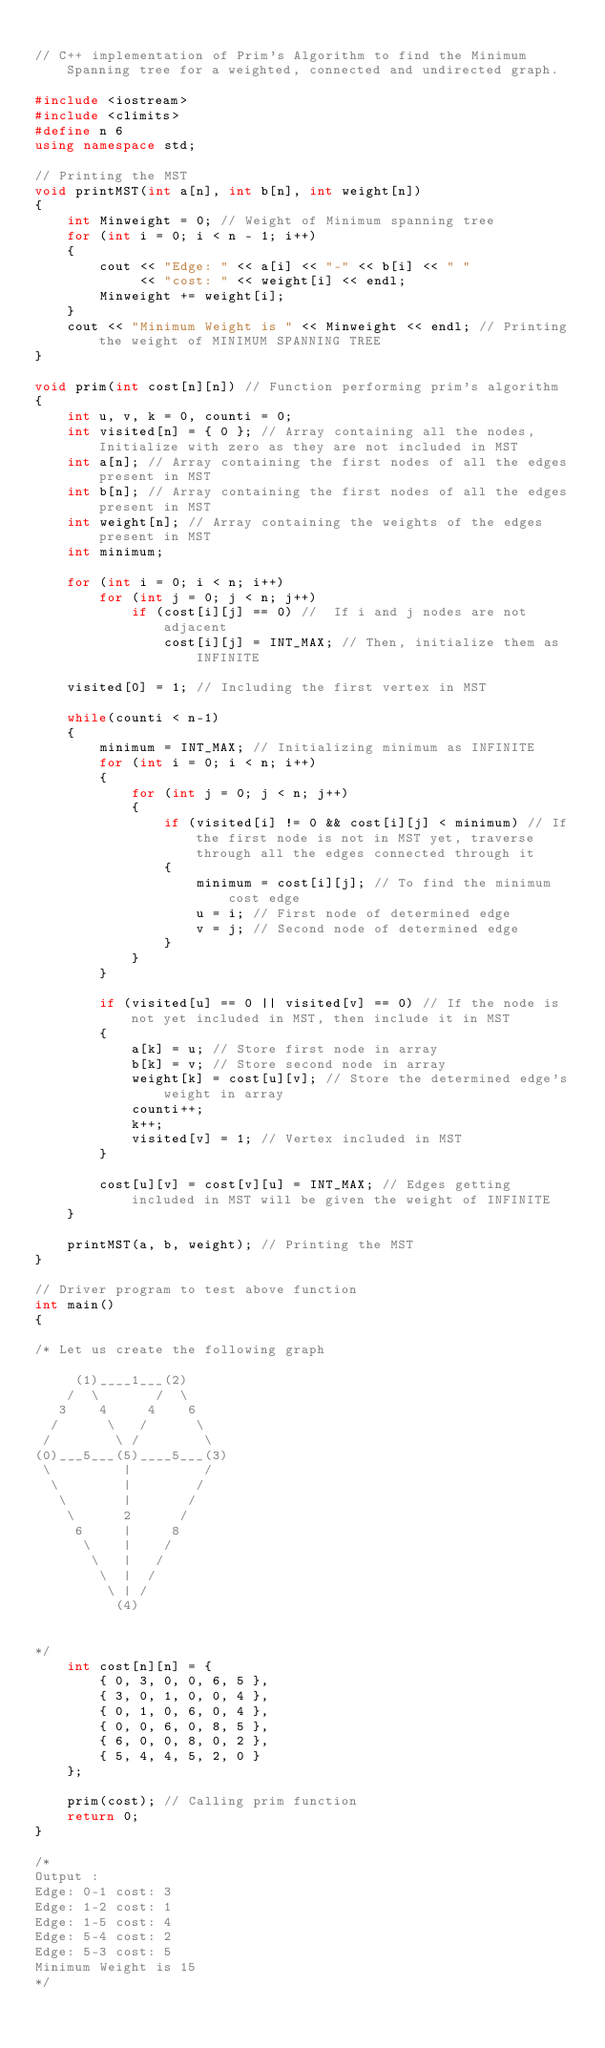<code> <loc_0><loc_0><loc_500><loc_500><_C++_>
// C++ implementation of Prim's Algorithm to find the Minimum Spanning tree for a weighted, connected and undirected graph.

#include <iostream>
#include <climits>
#define n 6
using namespace std;

// Printing the MST
void printMST(int a[n], int b[n], int weight[n])
{
    int Minweight = 0; // Weight of Minimum spanning tree
    for (int i = 0; i < n - 1; i++)
    {
        cout << "Edge: " << a[i] << "-" << b[i] << " "
             << "cost: " << weight[i] << endl;
        Minweight += weight[i];
    }
    cout << "Minimum Weight is " << Minweight << endl; // Printing the weight of MINIMUM SPANNING TREE
}

void prim(int cost[n][n]) // Function performing prim's algorithm
{
    int u, v, k = 0, counti = 0;
    int visited[n] = { 0 }; // Array containing all the nodes, Initialize with zero as they are not included in MST
    int a[n]; // Array containing the first nodes of all the edges present in MST
    int b[n]; // Array containing the first nodes of all the edges present in MST
    int weight[n]; // Array containing the weights of the edges present in MST
    int minimum;

    for (int i = 0; i < n; i++)
        for (int j = 0; j < n; j++)
            if (cost[i][j] == 0) //  If i and j nodes are not adjacent
                cost[i][j] = INT_MAX; // Then, initialize them as INFINITE

    visited[0] = 1; // Including the first vertex in MST

    while(counti < n-1)
    {
        minimum = INT_MAX; // Initializing minimum as INFINITE
        for (int i = 0; i < n; i++)
        {
            for (int j = 0; j < n; j++)
            {
                if (visited[i] != 0 && cost[i][j] < minimum) // If the first node is not in MST yet, traverse through all the edges connected through it
                {
                    minimum = cost[i][j]; // To find the minimum cost edge
                    u = i; // First node of determined edge
                    v = j; // Second node of determined edge
                }
            }
        }

        if (visited[u] == 0 || visited[v] == 0) // If the node is not yet included in MST, then include it in MST
        {
            a[k] = u; // Store first node in array
            b[k] = v; // Store second node in array
            weight[k] = cost[u][v]; // Store the determined edge's weight in array
            counti++;
            k++;
            visited[v] = 1; // Vertex included in MST
        }

        cost[u][v] = cost[v][u] = INT_MAX; // Edges getting included in MST will be given the weight of INFINITE
    }

    printMST(a, b, weight); // Printing the MST
}

// Driver program to test above function
int main()
{

/* Let us create the following graph

     (1)____1___(2)
    /  \       /  \
   3    4     4    6
  /      \   /      \
 /        \ /        \
(0)___5___(5)____5___(3)
 \         |         /
  \        |        /
   \       |       /
    \      2      /
     6     |     8
      \    |    /
       \   |   /
        \  |  /
         \ | /
          (4)


*/
    int cost[n][n] = {
        { 0, 3, 0, 0, 6, 5 },
        { 3, 0, 1, 0, 0, 4 },
        { 0, 1, 0, 6, 0, 4 },
        { 0, 0, 6, 0, 8, 5 },
        { 6, 0, 0, 8, 0, 2 },
        { 5, 4, 4, 5, 2, 0 }
    };

    prim(cost); // Calling prim function
    return 0;
}

/*
Output :
Edge: 0-1 cost: 3
Edge: 1-2 cost: 1
Edge: 1-5 cost: 4
Edge: 5-4 cost: 2
Edge: 5-3 cost: 5
Minimum Weight is 15
*/
</code> 